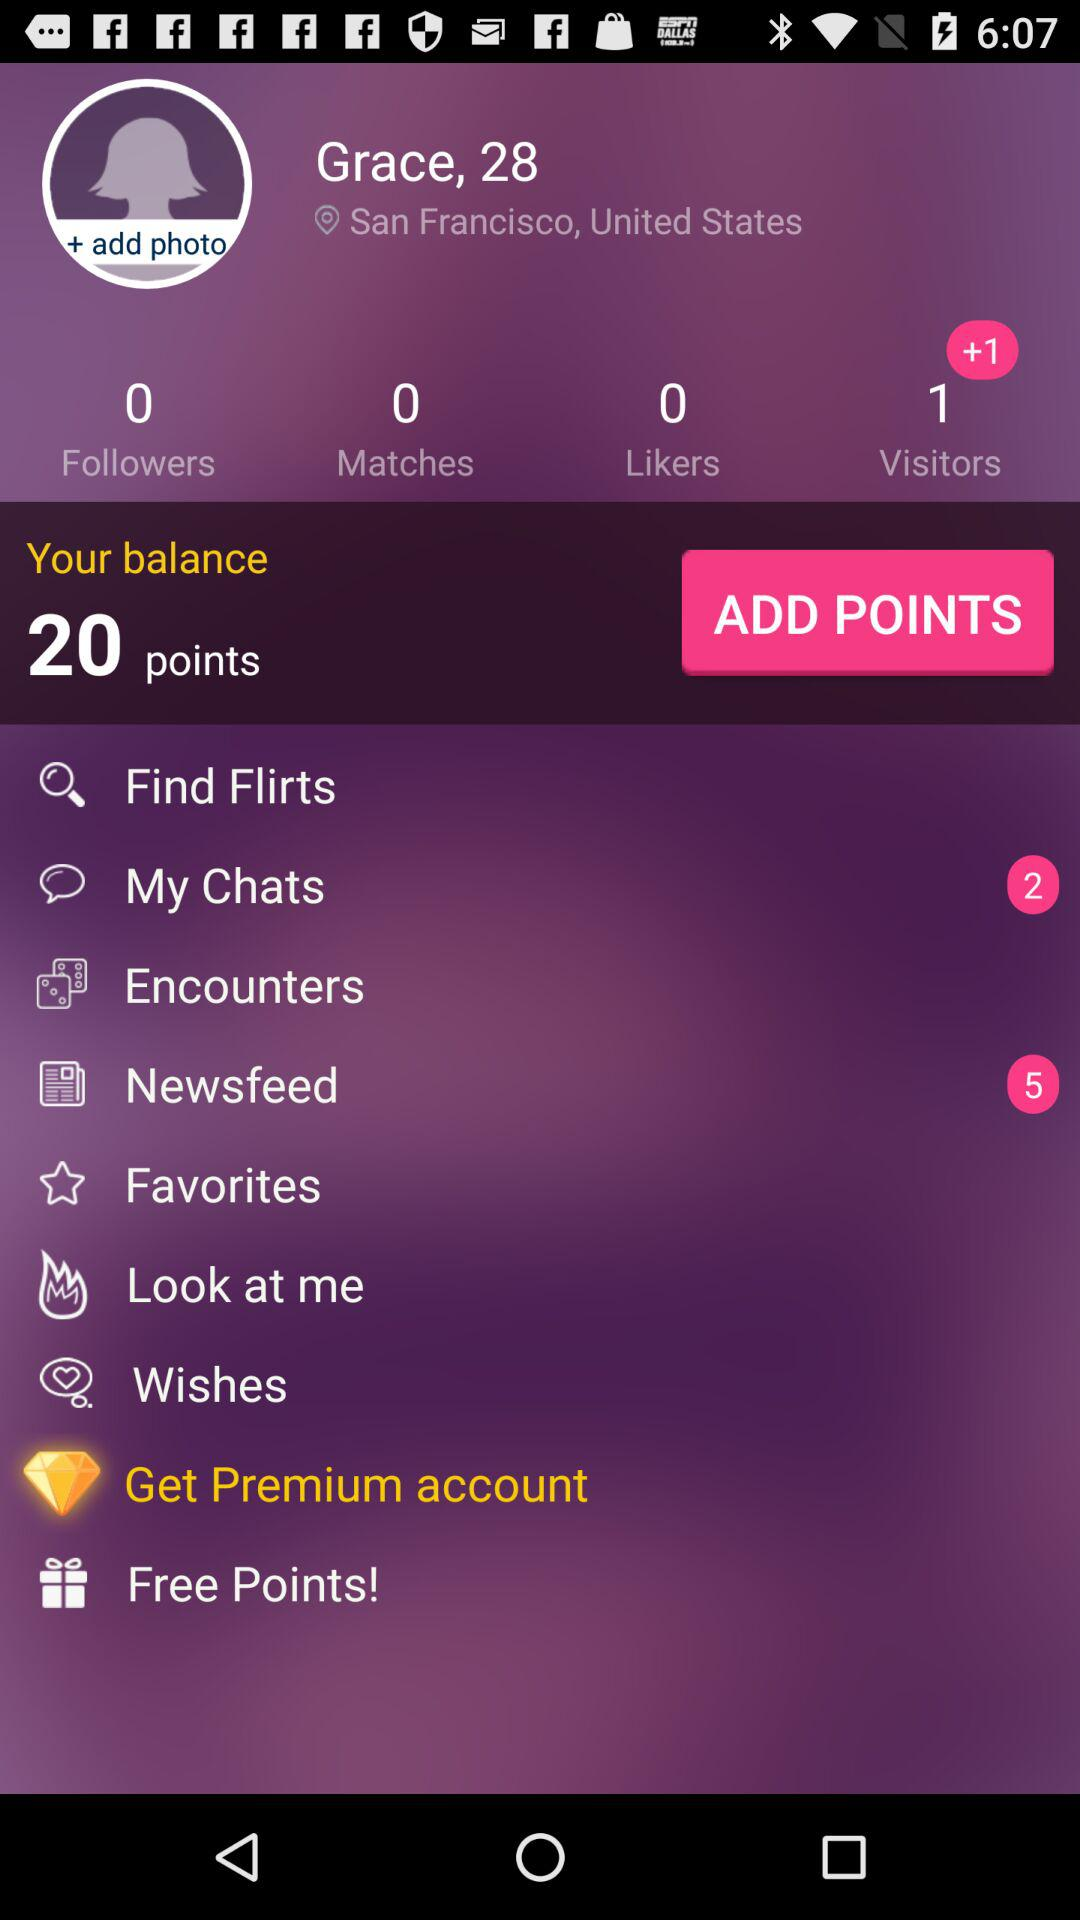What's the user's location? The user's location is San Francisco, United States. 